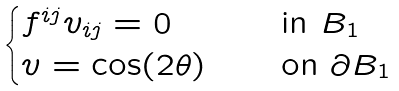Convert formula to latex. <formula><loc_0><loc_0><loc_500><loc_500>\begin{cases} f ^ { i j } v _ { i j } = 0 \quad & \text {in $B_{1}$} \\ v = \cos ( 2 \theta ) \quad & \text {on $\partial B_{1}$} \end{cases}</formula> 